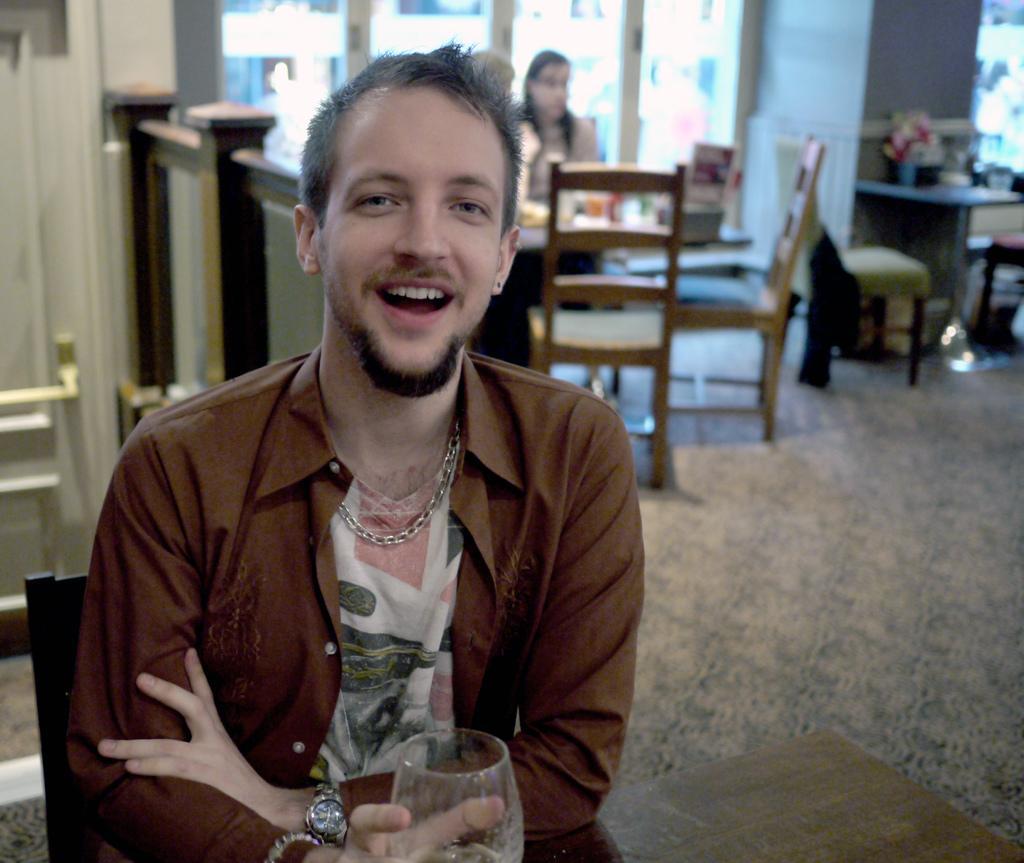Describe this image in one or two sentences. A man wearing a chain and a watch is holding a glass. Glass is on the table. There are many chair, tables in the background. Also a lady is sitting in the background. There is a flower vase on the table. There are window and wall in the background. 